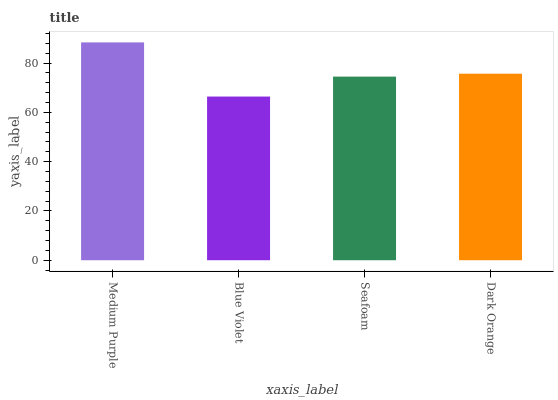Is Blue Violet the minimum?
Answer yes or no. Yes. Is Medium Purple the maximum?
Answer yes or no. Yes. Is Seafoam the minimum?
Answer yes or no. No. Is Seafoam the maximum?
Answer yes or no. No. Is Seafoam greater than Blue Violet?
Answer yes or no. Yes. Is Blue Violet less than Seafoam?
Answer yes or no. Yes. Is Blue Violet greater than Seafoam?
Answer yes or no. No. Is Seafoam less than Blue Violet?
Answer yes or no. No. Is Dark Orange the high median?
Answer yes or no. Yes. Is Seafoam the low median?
Answer yes or no. Yes. Is Seafoam the high median?
Answer yes or no. No. Is Blue Violet the low median?
Answer yes or no. No. 